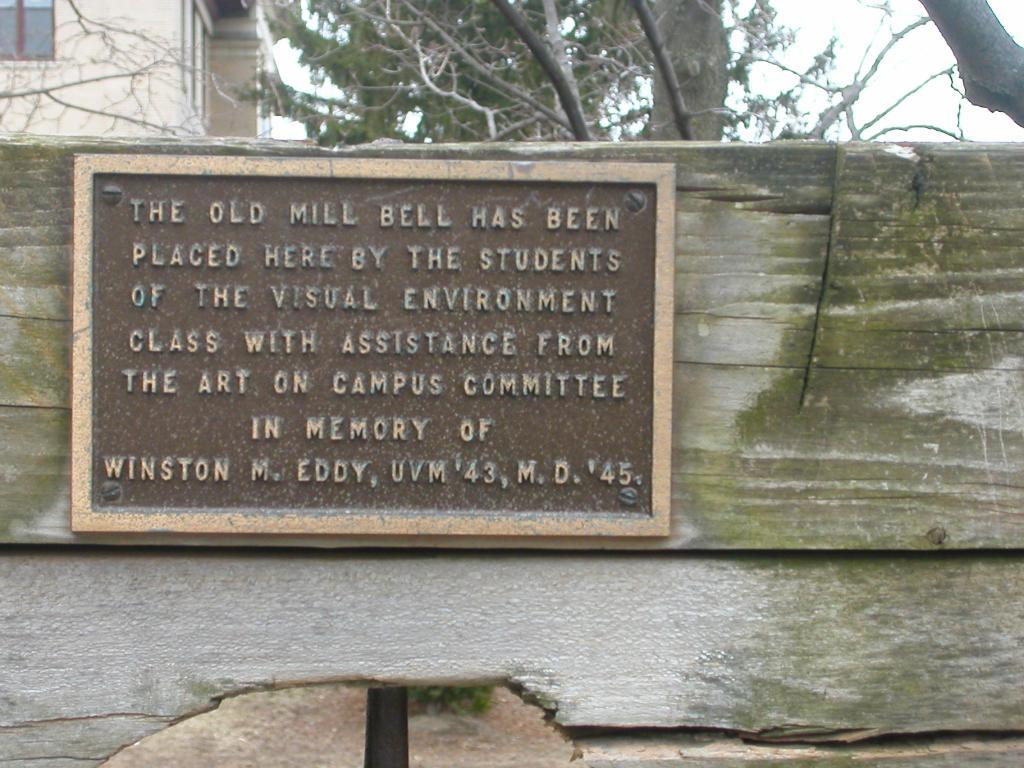What is the main object in the foreground of the image? There is a name board in the foreground of the image. What material is the name board placed on? The name board is placed on wood. What can be seen in the background of the image? There is a group of trees, a building, and the sky visible in the background of the image. Where is the crate located in the image? There is no crate present in the image. What type of hole can be seen in the image? There is no hole present in the image. 